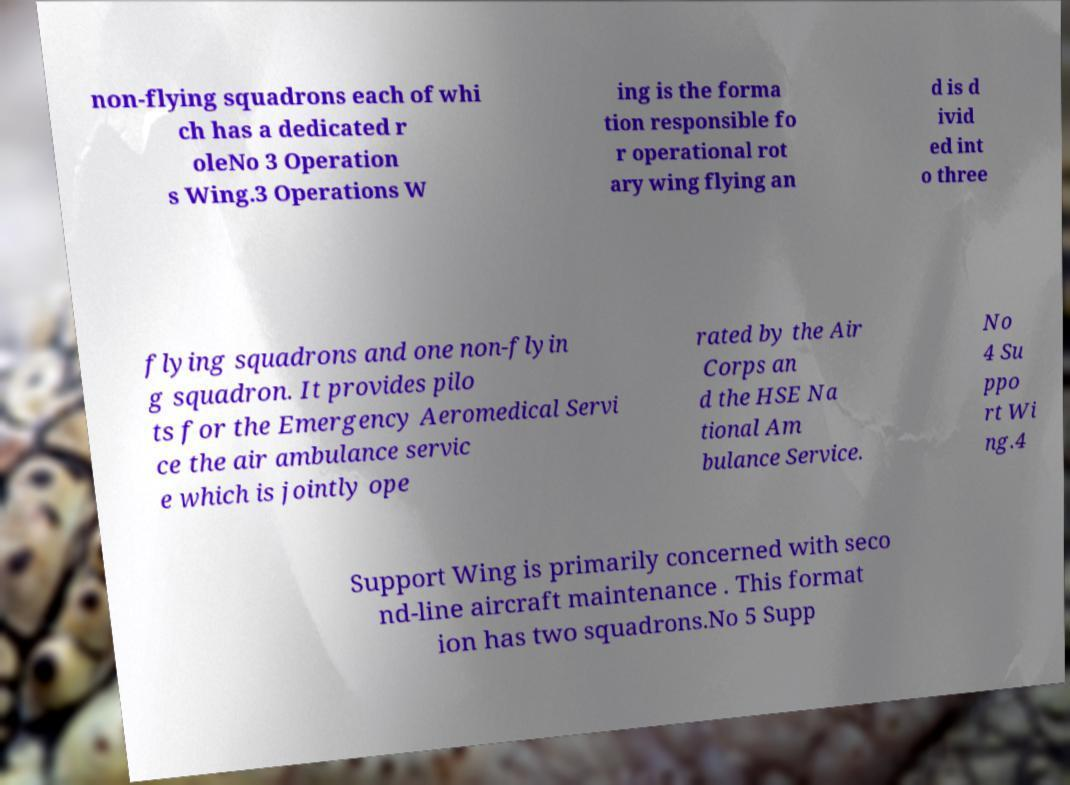For documentation purposes, I need the text within this image transcribed. Could you provide that? non-flying squadrons each of whi ch has a dedicated r oleNo 3 Operation s Wing.3 Operations W ing is the forma tion responsible fo r operational rot ary wing flying an d is d ivid ed int o three flying squadrons and one non-flyin g squadron. It provides pilo ts for the Emergency Aeromedical Servi ce the air ambulance servic e which is jointly ope rated by the Air Corps an d the HSE Na tional Am bulance Service. No 4 Su ppo rt Wi ng.4 Support Wing is primarily concerned with seco nd-line aircraft maintenance . This format ion has two squadrons.No 5 Supp 